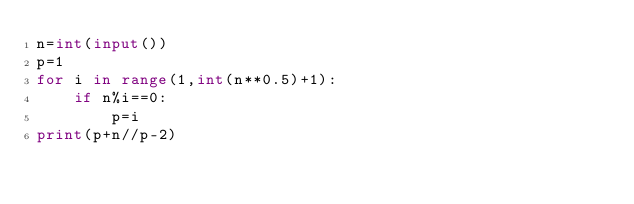<code> <loc_0><loc_0><loc_500><loc_500><_Python_>n=int(input())
p=1
for i in range(1,int(n**0.5)+1):
    if n%i==0:
        p=i
print(p+n//p-2)</code> 